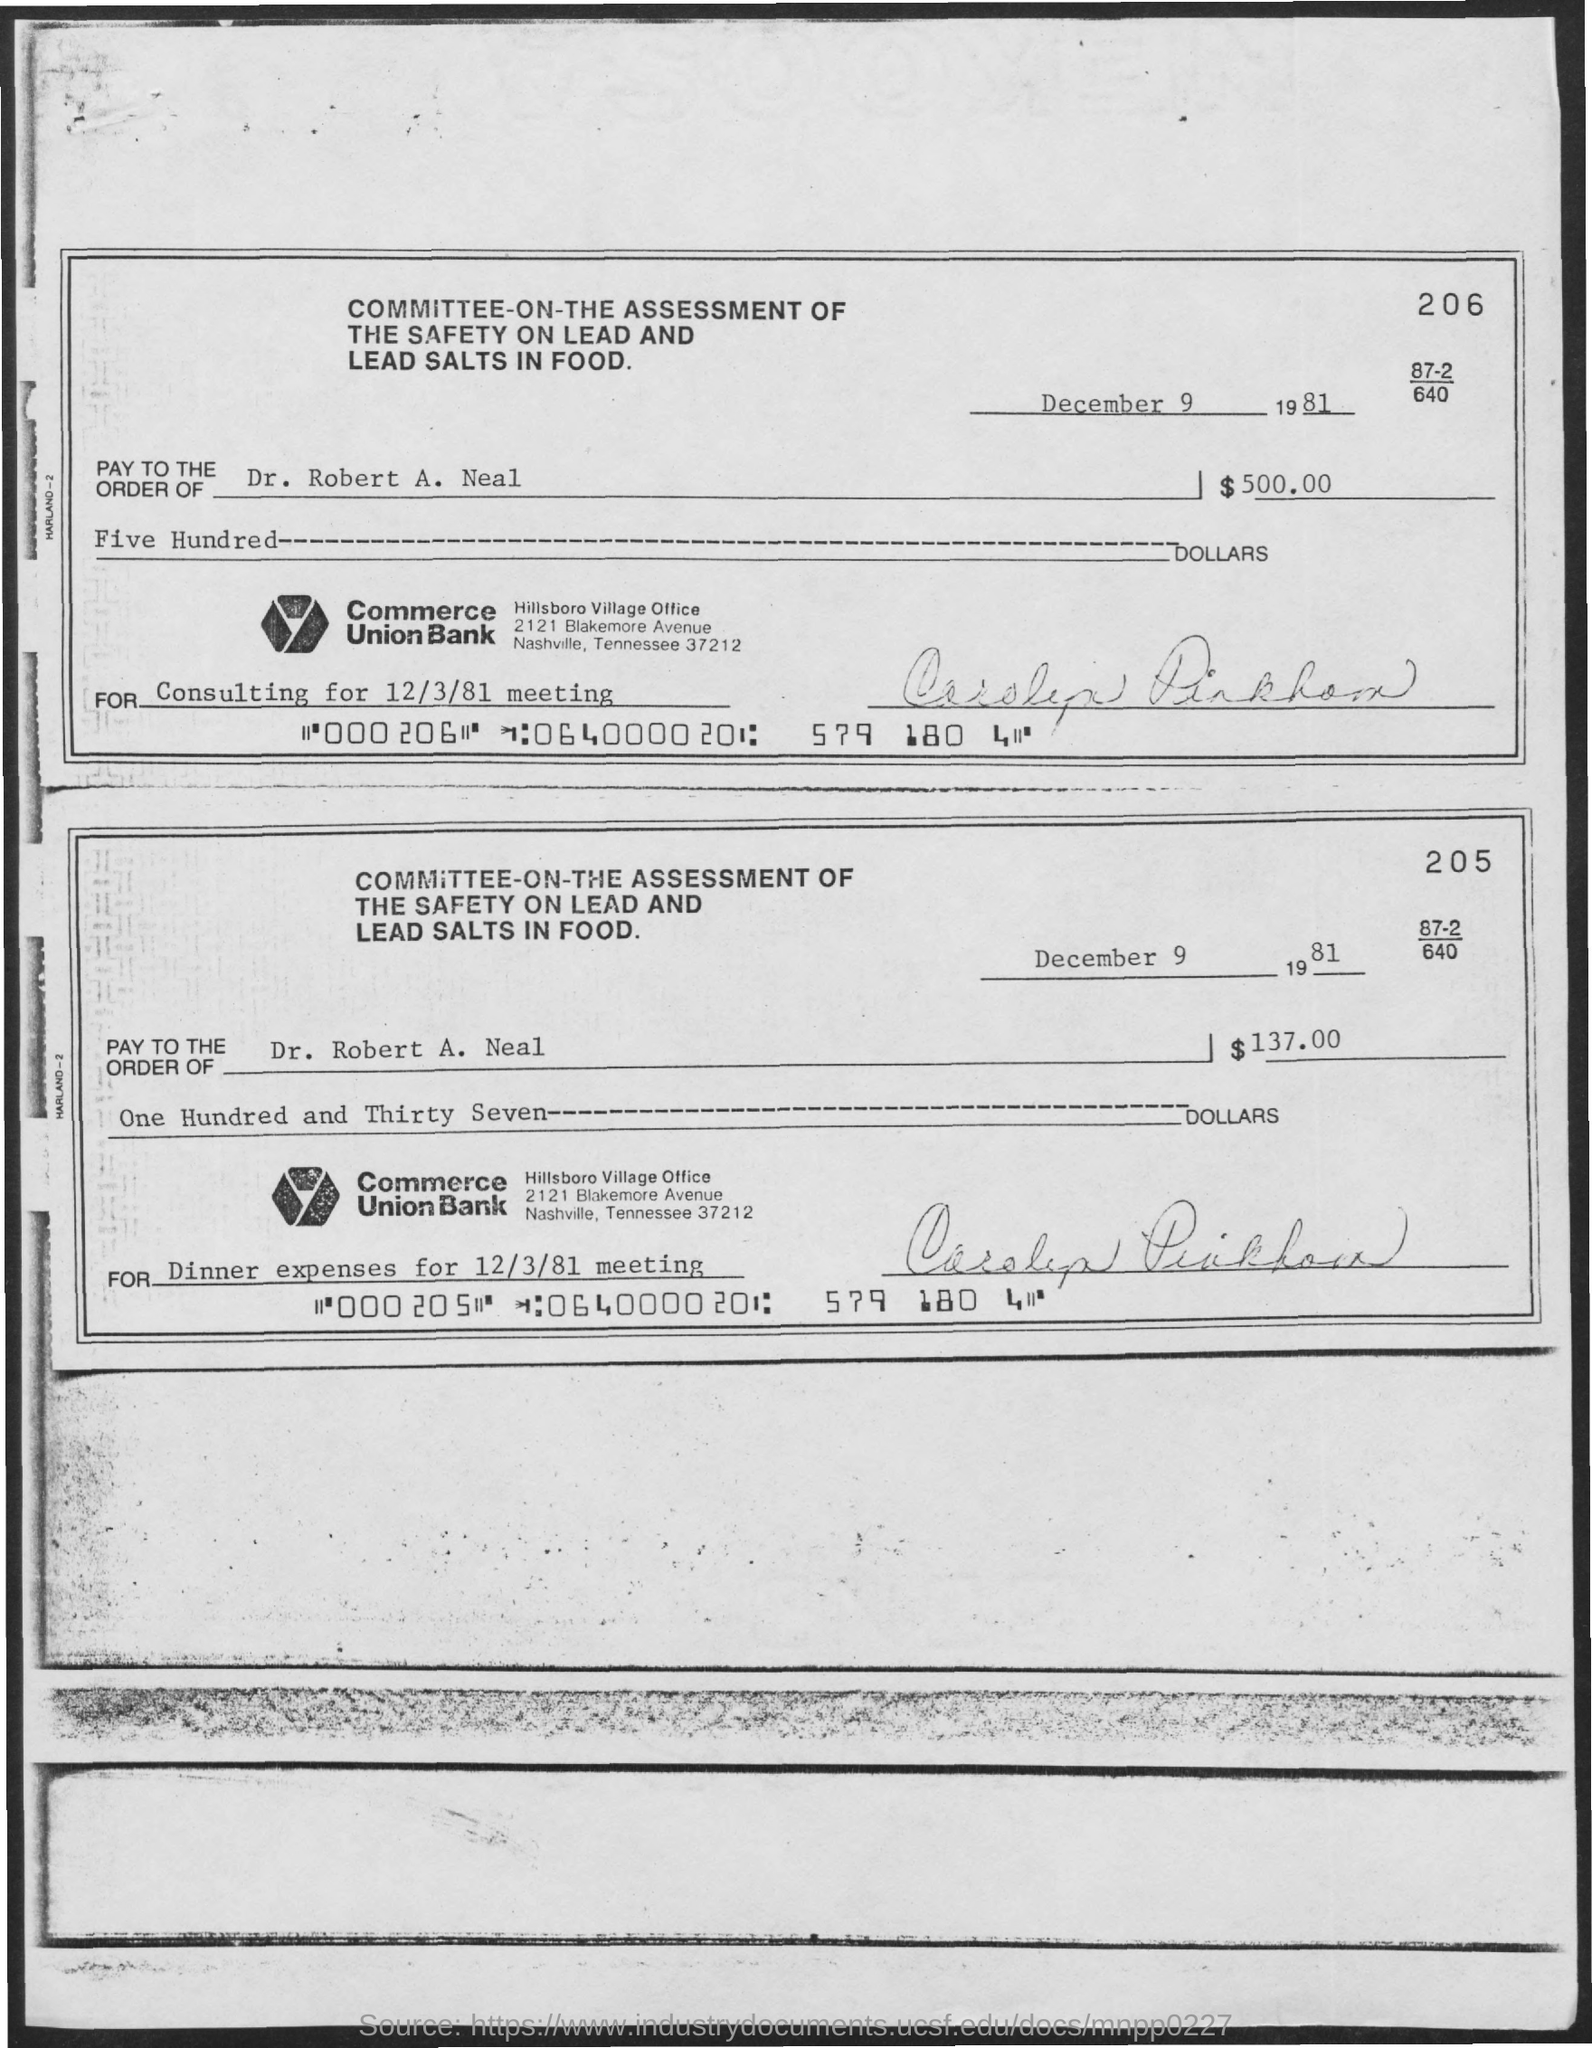When is the document dated?
Your response must be concise. December 9 1981. To whom should the check be paid?
Offer a very short reply. DR. ROBERT A. NEAL. What is the amount to be paid for consulting in dollars?
Offer a very short reply. $500.00. What is check 205 for?
Your response must be concise. DINNER EXPENSES FOR 12/3/81 MEETING. 